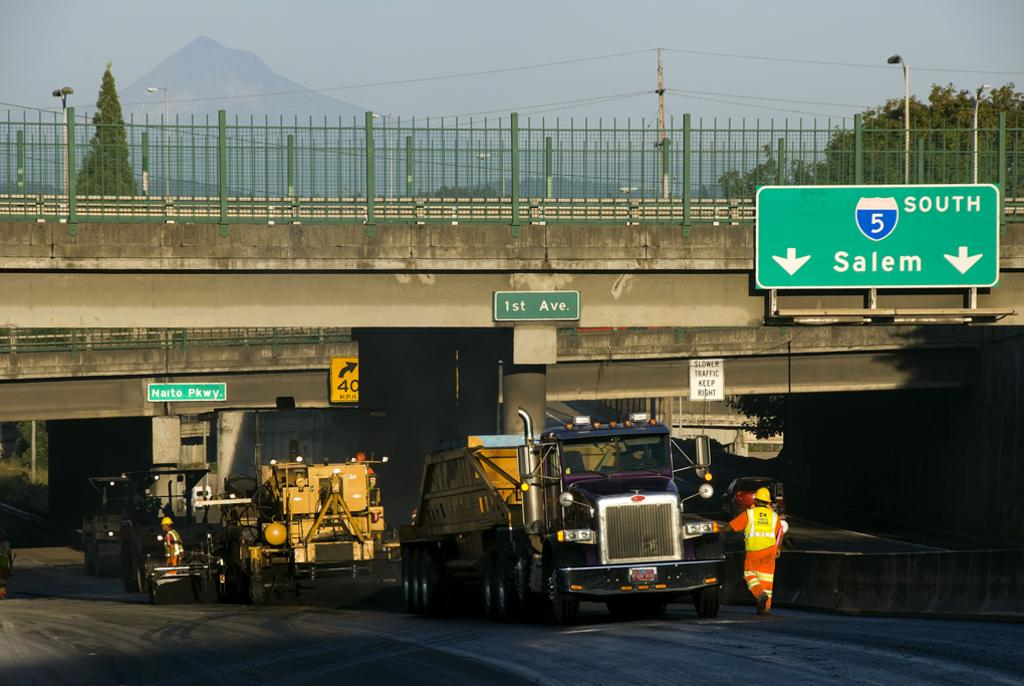What structure can be seen in the image? There is a bridge in the image. What type of vehicles are present in the image? There are trucks in the image. Can you describe the sign board on the right side of the image? There is a green color sign board on the right side of the image. What type of natural elements can be seen in the image? There are trees visible in the image. How would you describe the sky in the image? The sky is cloudy in the image. What type of jewel can be seen on the finger of the person in the image? There is no person present in the image, and therefore no finger or jewel can be observed. 